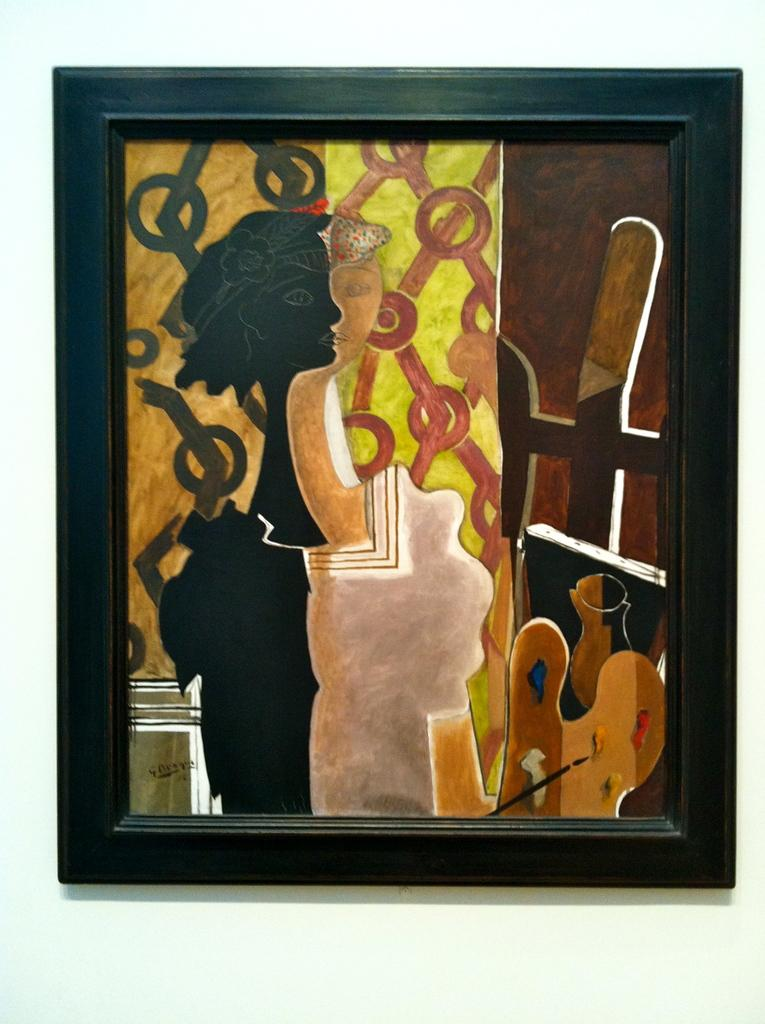What is the main subject in the image? There is a painting in the image. What can be seen around the painting? The painting has a frame. What is the color of the surface on which the painting is placed? The painting is on a white surface. Can you see the artist's ear in the image? There is no artist's ear visible in the image, as it only shows a painting with a frame on a white surface. 